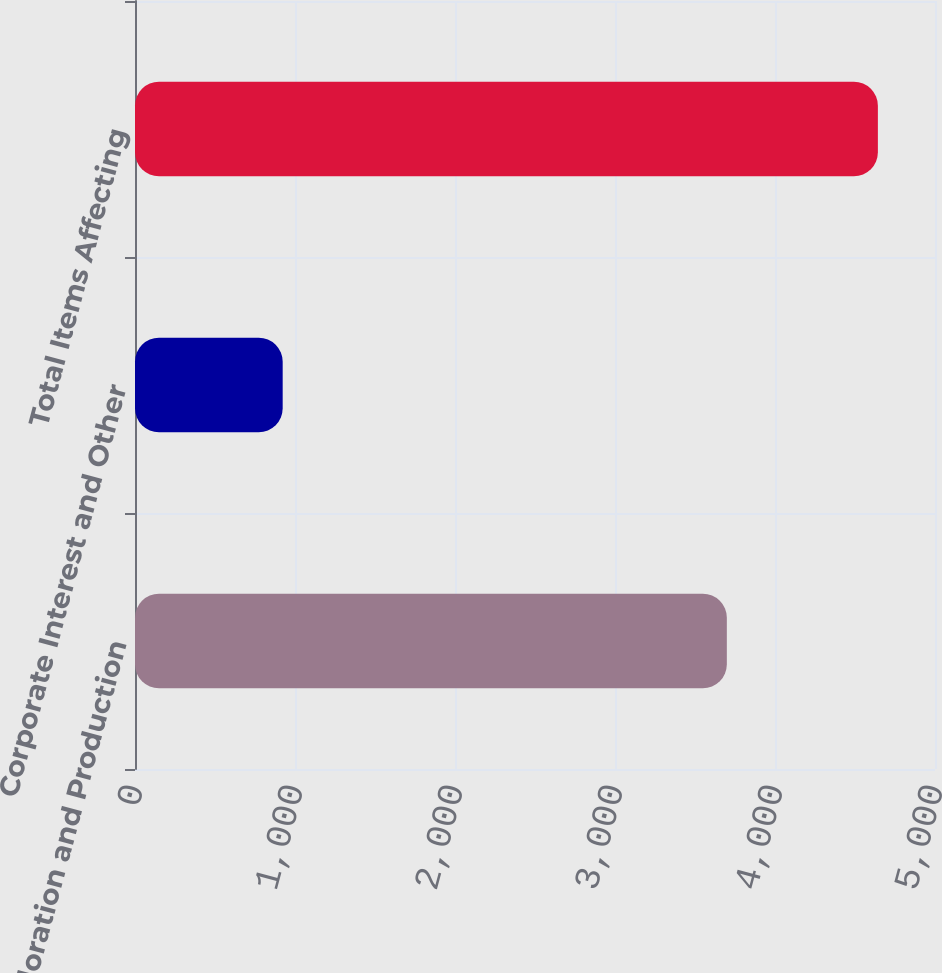Convert chart to OTSL. <chart><loc_0><loc_0><loc_500><loc_500><bar_chart><fcel>Exploration and Production<fcel>Corporate Interest and Other<fcel>Total Items Affecting<nl><fcel>3699<fcel>923<fcel>4643<nl></chart> 